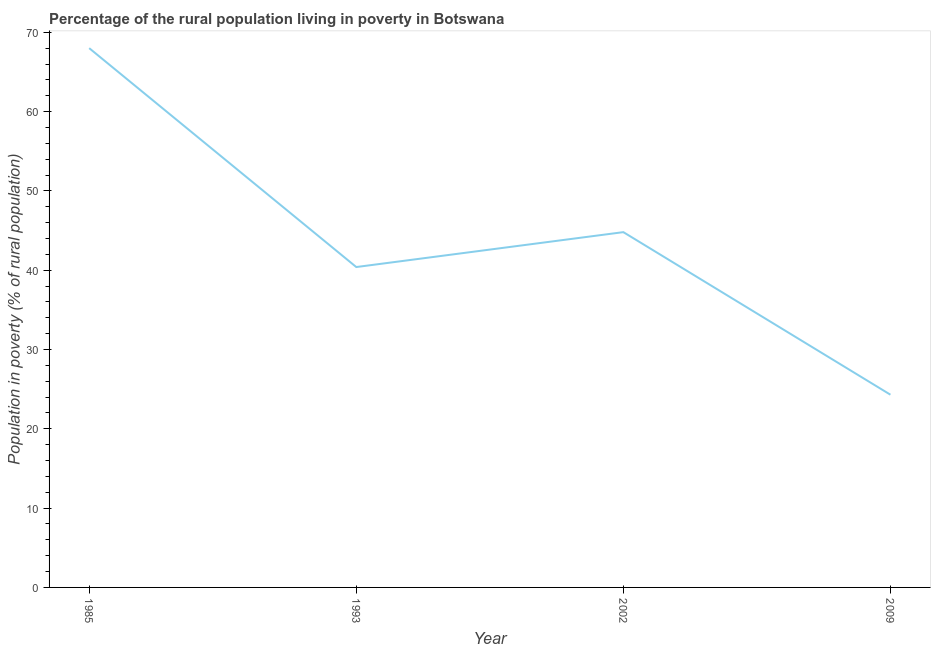What is the percentage of rural population living below poverty line in 1993?
Make the answer very short. 40.4. Across all years, what is the minimum percentage of rural population living below poverty line?
Provide a succinct answer. 24.3. In which year was the percentage of rural population living below poverty line maximum?
Your answer should be very brief. 1985. In which year was the percentage of rural population living below poverty line minimum?
Keep it short and to the point. 2009. What is the sum of the percentage of rural population living below poverty line?
Offer a very short reply. 177.5. What is the difference between the percentage of rural population living below poverty line in 1985 and 2002?
Your answer should be compact. 23.2. What is the average percentage of rural population living below poverty line per year?
Offer a very short reply. 44.38. What is the median percentage of rural population living below poverty line?
Ensure brevity in your answer.  42.6. In how many years, is the percentage of rural population living below poverty line greater than 48 %?
Provide a short and direct response. 1. What is the ratio of the percentage of rural population living below poverty line in 1993 to that in 2002?
Offer a very short reply. 0.9. Is the percentage of rural population living below poverty line in 1993 less than that in 2009?
Provide a succinct answer. No. Is the difference between the percentage of rural population living below poverty line in 1993 and 2002 greater than the difference between any two years?
Make the answer very short. No. What is the difference between the highest and the second highest percentage of rural population living below poverty line?
Your answer should be compact. 23.2. Is the sum of the percentage of rural population living below poverty line in 1993 and 2009 greater than the maximum percentage of rural population living below poverty line across all years?
Give a very brief answer. No. What is the difference between the highest and the lowest percentage of rural population living below poverty line?
Offer a very short reply. 43.7. Does the percentage of rural population living below poverty line monotonically increase over the years?
Your response must be concise. No. How many lines are there?
Your response must be concise. 1. How many years are there in the graph?
Keep it short and to the point. 4. Does the graph contain any zero values?
Provide a short and direct response. No. What is the title of the graph?
Keep it short and to the point. Percentage of the rural population living in poverty in Botswana. What is the label or title of the X-axis?
Your answer should be very brief. Year. What is the label or title of the Y-axis?
Give a very brief answer. Population in poverty (% of rural population). What is the Population in poverty (% of rural population) of 1985?
Make the answer very short. 68. What is the Population in poverty (% of rural population) of 1993?
Give a very brief answer. 40.4. What is the Population in poverty (% of rural population) in 2002?
Your answer should be compact. 44.8. What is the Population in poverty (% of rural population) in 2009?
Give a very brief answer. 24.3. What is the difference between the Population in poverty (% of rural population) in 1985 and 1993?
Ensure brevity in your answer.  27.6. What is the difference between the Population in poverty (% of rural population) in 1985 and 2002?
Your answer should be very brief. 23.2. What is the difference between the Population in poverty (% of rural population) in 1985 and 2009?
Make the answer very short. 43.7. What is the ratio of the Population in poverty (% of rural population) in 1985 to that in 1993?
Your response must be concise. 1.68. What is the ratio of the Population in poverty (% of rural population) in 1985 to that in 2002?
Offer a very short reply. 1.52. What is the ratio of the Population in poverty (% of rural population) in 1985 to that in 2009?
Offer a terse response. 2.8. What is the ratio of the Population in poverty (% of rural population) in 1993 to that in 2002?
Offer a very short reply. 0.9. What is the ratio of the Population in poverty (% of rural population) in 1993 to that in 2009?
Offer a very short reply. 1.66. What is the ratio of the Population in poverty (% of rural population) in 2002 to that in 2009?
Provide a short and direct response. 1.84. 